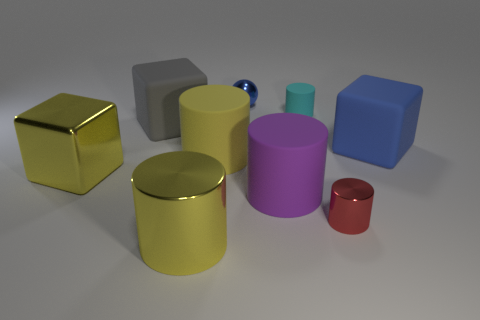Subtract all tiny red cylinders. How many cylinders are left? 4 Add 1 large purple rubber cylinders. How many objects exist? 10 Subtract 1 cylinders. How many cylinders are left? 4 Subtract all yellow cylinders. How many cylinders are left? 3 Subtract 0 blue cylinders. How many objects are left? 9 Subtract all cylinders. How many objects are left? 4 Subtract all gray cubes. Subtract all gray spheres. How many cubes are left? 2 Subtract all blue blocks. How many red cylinders are left? 1 Subtract all red metal cylinders. Subtract all big matte cylinders. How many objects are left? 6 Add 4 yellow matte cylinders. How many yellow matte cylinders are left? 5 